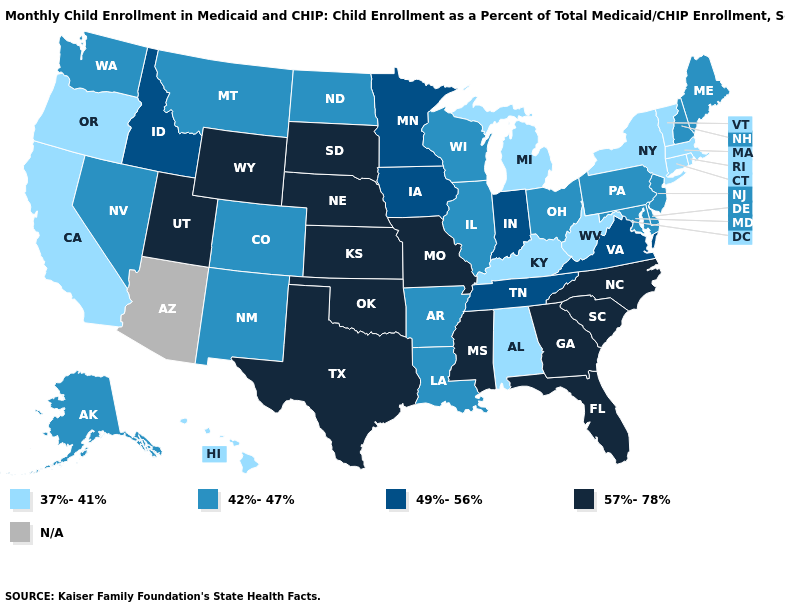Does Pennsylvania have the highest value in the Northeast?
Keep it brief. Yes. What is the lowest value in the USA?
Quick response, please. 37%-41%. What is the value of Missouri?
Answer briefly. 57%-78%. What is the highest value in the South ?
Answer briefly. 57%-78%. Name the states that have a value in the range 49%-56%?
Be succinct. Idaho, Indiana, Iowa, Minnesota, Tennessee, Virginia. Name the states that have a value in the range 37%-41%?
Concise answer only. Alabama, California, Connecticut, Hawaii, Kentucky, Massachusetts, Michigan, New York, Oregon, Rhode Island, Vermont, West Virginia. Name the states that have a value in the range 57%-78%?
Answer briefly. Florida, Georgia, Kansas, Mississippi, Missouri, Nebraska, North Carolina, Oklahoma, South Carolina, South Dakota, Texas, Utah, Wyoming. Which states hav the highest value in the South?
Short answer required. Florida, Georgia, Mississippi, North Carolina, Oklahoma, South Carolina, Texas. What is the value of Arizona?
Give a very brief answer. N/A. What is the value of Idaho?
Concise answer only. 49%-56%. Name the states that have a value in the range 49%-56%?
Quick response, please. Idaho, Indiana, Iowa, Minnesota, Tennessee, Virginia. What is the lowest value in the USA?
Give a very brief answer. 37%-41%. Name the states that have a value in the range 42%-47%?
Concise answer only. Alaska, Arkansas, Colorado, Delaware, Illinois, Louisiana, Maine, Maryland, Montana, Nevada, New Hampshire, New Jersey, New Mexico, North Dakota, Ohio, Pennsylvania, Washington, Wisconsin. What is the value of Kansas?
Concise answer only. 57%-78%. What is the value of Florida?
Keep it brief. 57%-78%. 